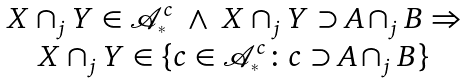<formula> <loc_0><loc_0><loc_500><loc_500>\begin{array} { c } X \cap _ { j } Y \in \mathcal { A } _ { ^ { * } } ^ { c } \ \land \ X \cap _ { j } Y \supset A \cap _ { j } B \Rightarrow \\ X \cap _ { j } Y \in \{ c \in \mathcal { A } _ { ^ { * } } ^ { c } \colon c \supset A \cap _ { j } B \} \end{array}</formula> 